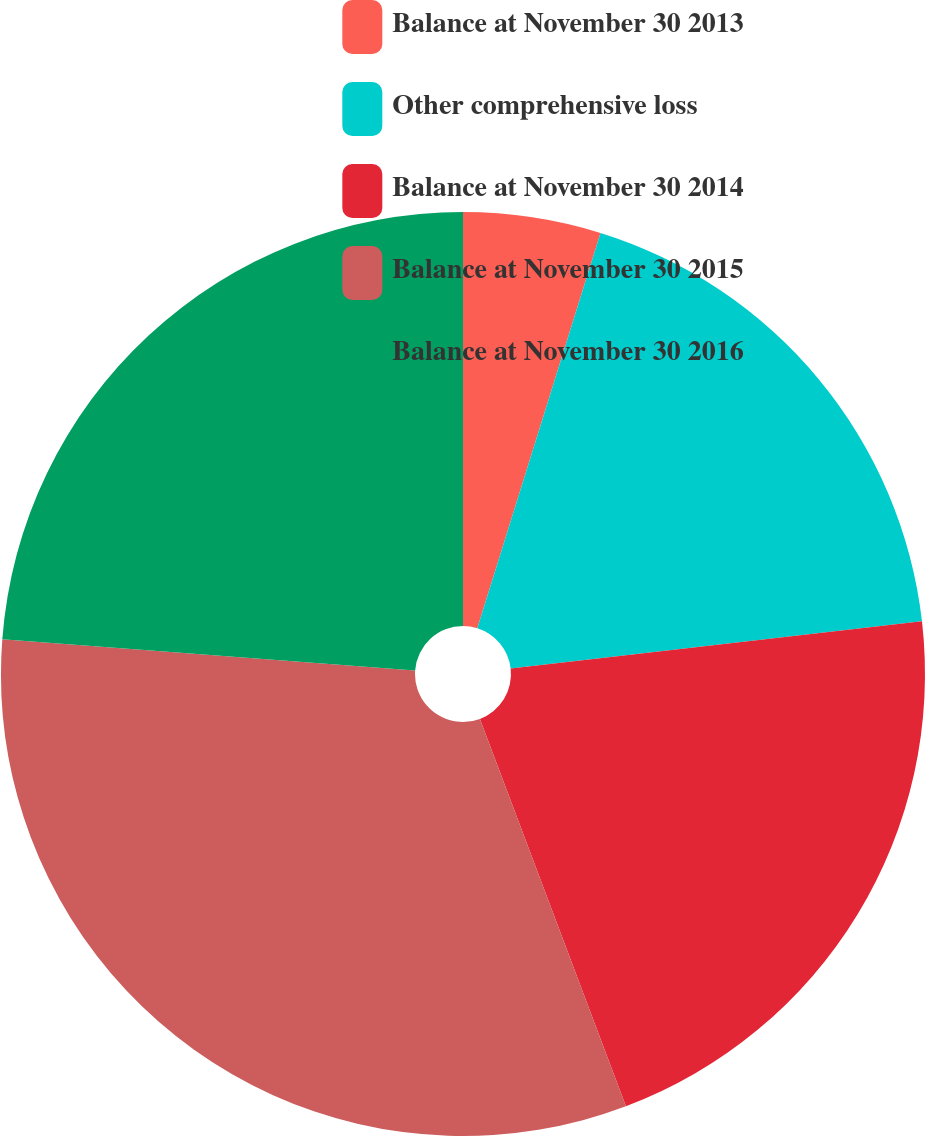<chart> <loc_0><loc_0><loc_500><loc_500><pie_chart><fcel>Balance at November 30 2013<fcel>Other comprehensive loss<fcel>Balance at November 30 2014<fcel>Balance at November 30 2015<fcel>Balance at November 30 2016<nl><fcel>4.81%<fcel>18.37%<fcel>21.08%<fcel>31.93%<fcel>23.8%<nl></chart> 